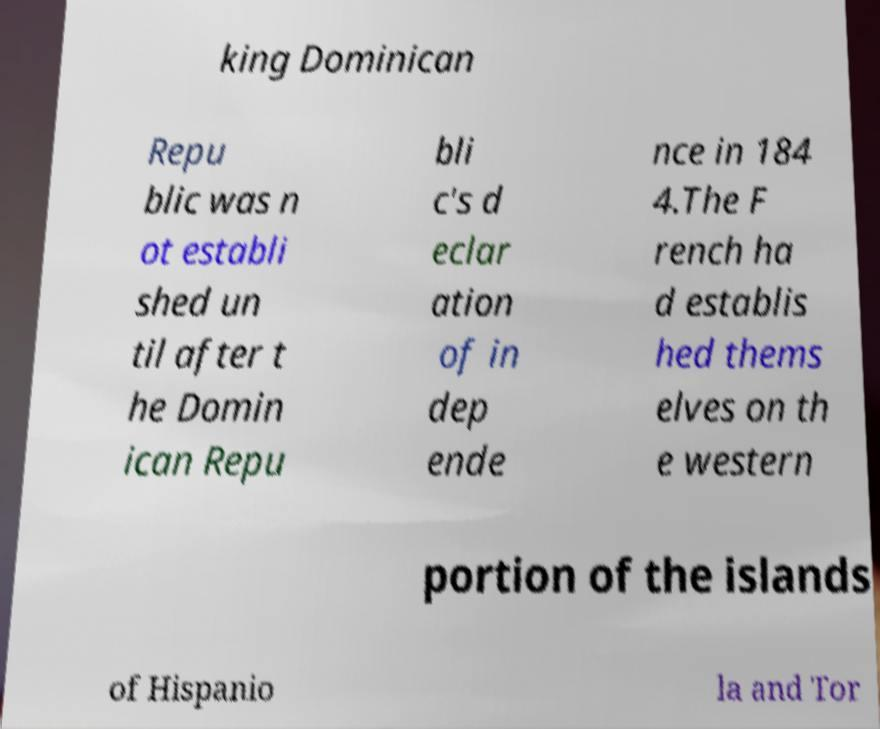Can you read and provide the text displayed in the image?This photo seems to have some interesting text. Can you extract and type it out for me? king Dominican Repu blic was n ot establi shed un til after t he Domin ican Repu bli c's d eclar ation of in dep ende nce in 184 4.The F rench ha d establis hed thems elves on th e western portion of the islands of Hispanio la and Tor 